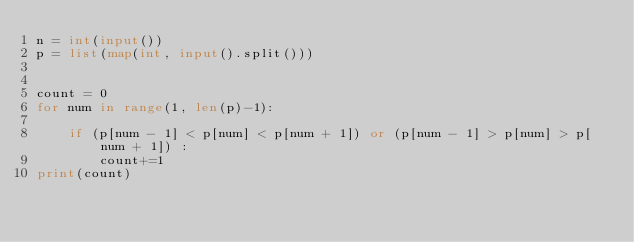<code> <loc_0><loc_0><loc_500><loc_500><_Python_>n = int(input())
p = list(map(int, input().split()))


count = 0
for num in range(1, len(p)-1):

    if (p[num - 1] < p[num] < p[num + 1]) or (p[num - 1] > p[num] > p[num + 1]) :
        count+=1
print(count)</code> 